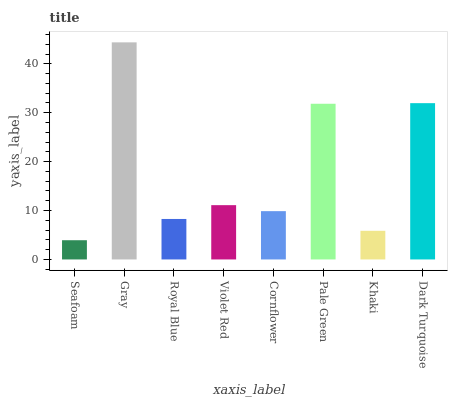Is Seafoam the minimum?
Answer yes or no. Yes. Is Gray the maximum?
Answer yes or no. Yes. Is Royal Blue the minimum?
Answer yes or no. No. Is Royal Blue the maximum?
Answer yes or no. No. Is Gray greater than Royal Blue?
Answer yes or no. Yes. Is Royal Blue less than Gray?
Answer yes or no. Yes. Is Royal Blue greater than Gray?
Answer yes or no. No. Is Gray less than Royal Blue?
Answer yes or no. No. Is Violet Red the high median?
Answer yes or no. Yes. Is Cornflower the low median?
Answer yes or no. Yes. Is Cornflower the high median?
Answer yes or no. No. Is Pale Green the low median?
Answer yes or no. No. 